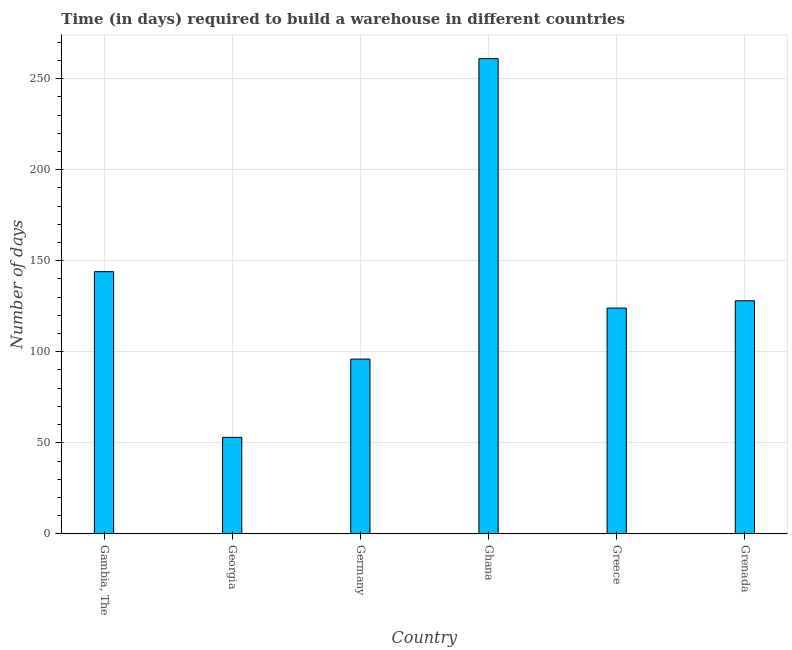Does the graph contain any zero values?
Your response must be concise. No. Does the graph contain grids?
Ensure brevity in your answer.  Yes. What is the title of the graph?
Give a very brief answer. Time (in days) required to build a warehouse in different countries. What is the label or title of the Y-axis?
Offer a terse response. Number of days. What is the time required to build a warehouse in Greece?
Give a very brief answer. 124. Across all countries, what is the maximum time required to build a warehouse?
Your answer should be compact. 261. In which country was the time required to build a warehouse maximum?
Make the answer very short. Ghana. In which country was the time required to build a warehouse minimum?
Keep it short and to the point. Georgia. What is the sum of the time required to build a warehouse?
Offer a very short reply. 806. What is the difference between the time required to build a warehouse in Georgia and Grenada?
Your answer should be very brief. -75. What is the average time required to build a warehouse per country?
Your answer should be very brief. 134.33. What is the median time required to build a warehouse?
Your response must be concise. 126. What is the difference between the highest and the second highest time required to build a warehouse?
Your response must be concise. 117. Is the sum of the time required to build a warehouse in Georgia and Greece greater than the maximum time required to build a warehouse across all countries?
Your answer should be very brief. No. What is the difference between the highest and the lowest time required to build a warehouse?
Offer a very short reply. 208. Are all the bars in the graph horizontal?
Offer a terse response. No. How many countries are there in the graph?
Your response must be concise. 6. What is the difference between two consecutive major ticks on the Y-axis?
Your answer should be compact. 50. Are the values on the major ticks of Y-axis written in scientific E-notation?
Your response must be concise. No. What is the Number of days of Gambia, The?
Keep it short and to the point. 144. What is the Number of days of Germany?
Make the answer very short. 96. What is the Number of days in Ghana?
Keep it short and to the point. 261. What is the Number of days of Greece?
Offer a very short reply. 124. What is the Number of days of Grenada?
Your response must be concise. 128. What is the difference between the Number of days in Gambia, The and Georgia?
Your response must be concise. 91. What is the difference between the Number of days in Gambia, The and Ghana?
Provide a short and direct response. -117. What is the difference between the Number of days in Gambia, The and Greece?
Offer a very short reply. 20. What is the difference between the Number of days in Gambia, The and Grenada?
Offer a very short reply. 16. What is the difference between the Number of days in Georgia and Germany?
Offer a terse response. -43. What is the difference between the Number of days in Georgia and Ghana?
Your answer should be compact. -208. What is the difference between the Number of days in Georgia and Greece?
Provide a short and direct response. -71. What is the difference between the Number of days in Georgia and Grenada?
Ensure brevity in your answer.  -75. What is the difference between the Number of days in Germany and Ghana?
Make the answer very short. -165. What is the difference between the Number of days in Germany and Greece?
Your response must be concise. -28. What is the difference between the Number of days in Germany and Grenada?
Ensure brevity in your answer.  -32. What is the difference between the Number of days in Ghana and Greece?
Your response must be concise. 137. What is the difference between the Number of days in Ghana and Grenada?
Your answer should be very brief. 133. What is the difference between the Number of days in Greece and Grenada?
Make the answer very short. -4. What is the ratio of the Number of days in Gambia, The to that in Georgia?
Keep it short and to the point. 2.72. What is the ratio of the Number of days in Gambia, The to that in Ghana?
Keep it short and to the point. 0.55. What is the ratio of the Number of days in Gambia, The to that in Greece?
Keep it short and to the point. 1.16. What is the ratio of the Number of days in Georgia to that in Germany?
Your response must be concise. 0.55. What is the ratio of the Number of days in Georgia to that in Ghana?
Give a very brief answer. 0.2. What is the ratio of the Number of days in Georgia to that in Greece?
Your answer should be very brief. 0.43. What is the ratio of the Number of days in Georgia to that in Grenada?
Your answer should be very brief. 0.41. What is the ratio of the Number of days in Germany to that in Ghana?
Offer a terse response. 0.37. What is the ratio of the Number of days in Germany to that in Greece?
Make the answer very short. 0.77. What is the ratio of the Number of days in Germany to that in Grenada?
Provide a short and direct response. 0.75. What is the ratio of the Number of days in Ghana to that in Greece?
Ensure brevity in your answer.  2.1. What is the ratio of the Number of days in Ghana to that in Grenada?
Offer a very short reply. 2.04. What is the ratio of the Number of days in Greece to that in Grenada?
Keep it short and to the point. 0.97. 